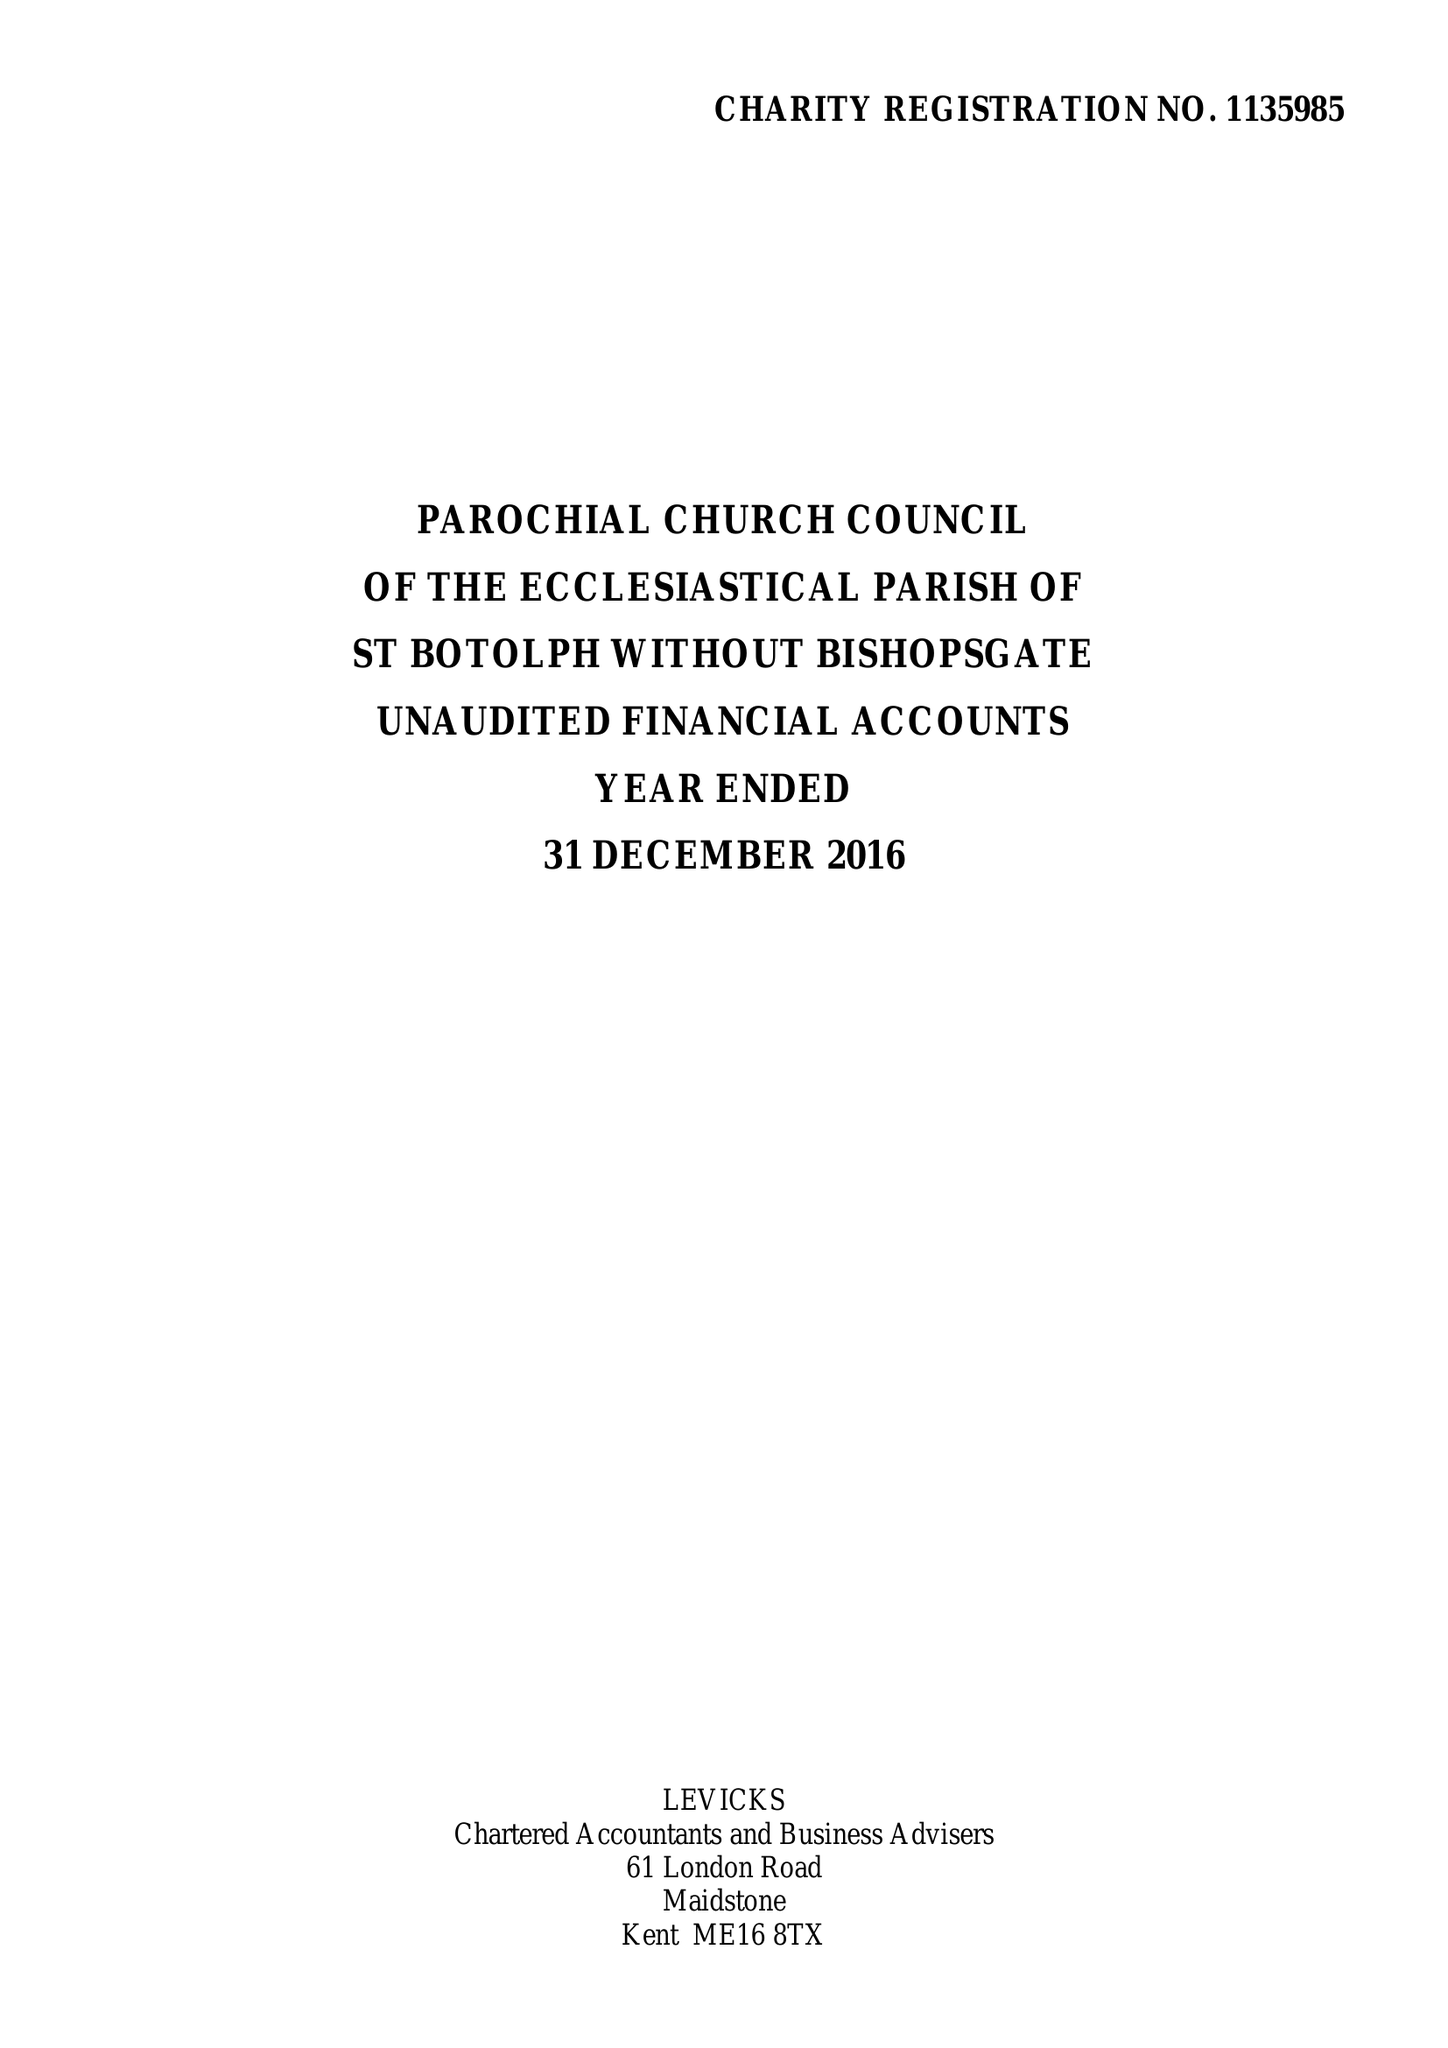What is the value for the address__postcode?
Answer the question using a single word or phrase. EC2M 3TL 